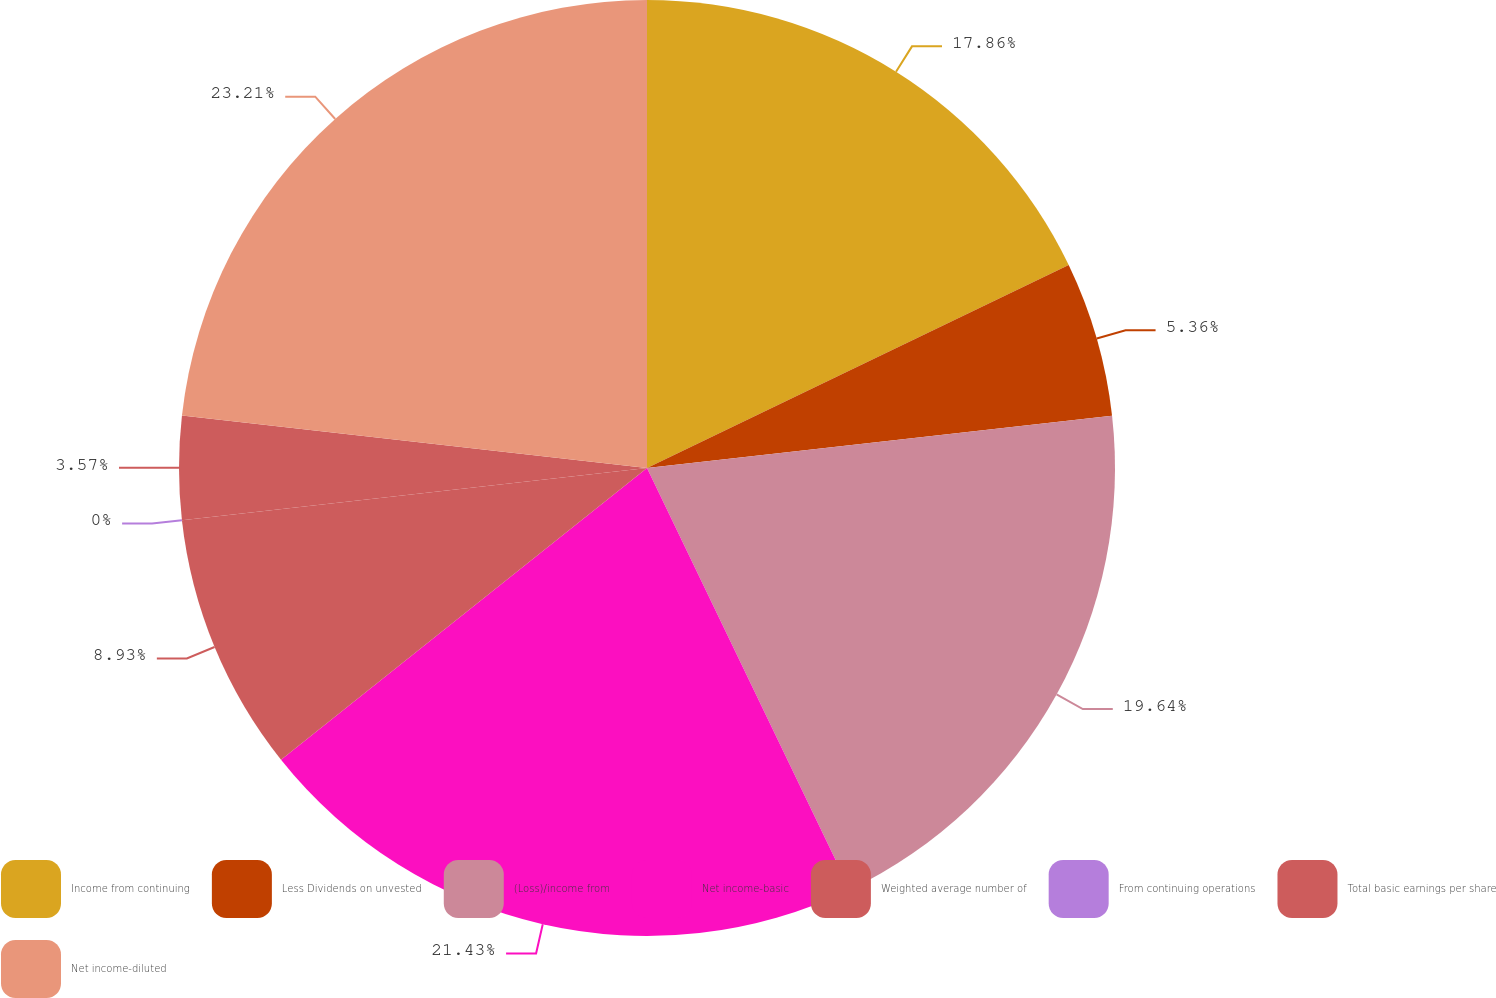Convert chart to OTSL. <chart><loc_0><loc_0><loc_500><loc_500><pie_chart><fcel>Income from continuing<fcel>Less Dividends on unvested<fcel>(Loss)/income from<fcel>Net income-basic<fcel>Weighted average number of<fcel>From continuing operations<fcel>Total basic earnings per share<fcel>Net income-diluted<nl><fcel>17.86%<fcel>5.36%<fcel>19.64%<fcel>21.43%<fcel>8.93%<fcel>0.0%<fcel>3.57%<fcel>23.21%<nl></chart> 